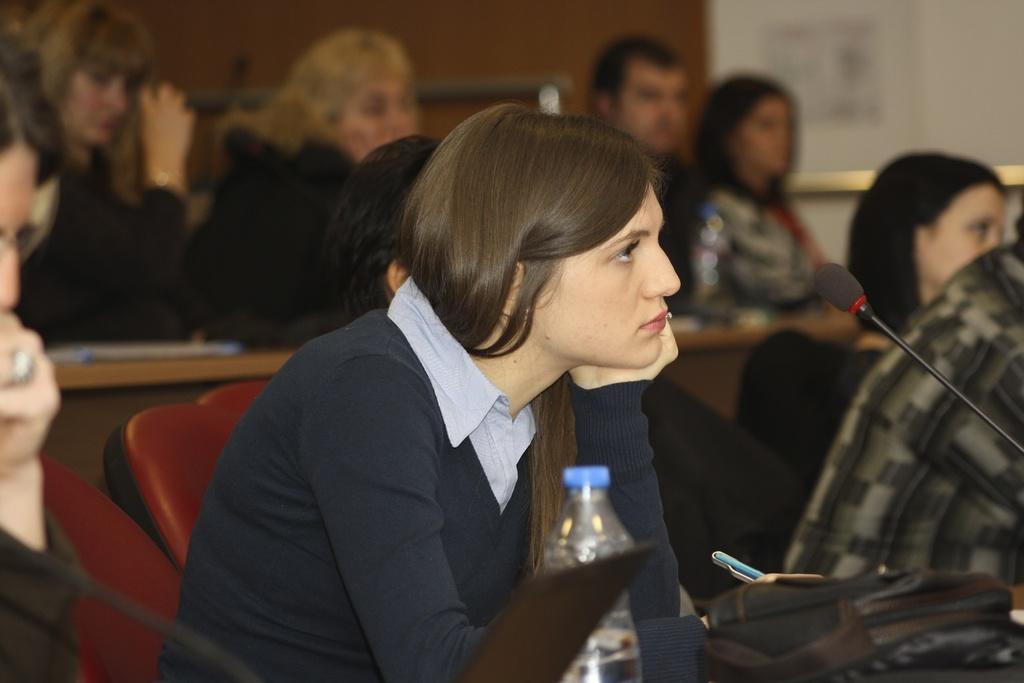Can you describe this image briefly? Every person is sitting on a chair. In-front of this woman there is a table, on a table there is a bag, bottle and laptop. This woman wore blue t-shirt and holds pens. A mic. 